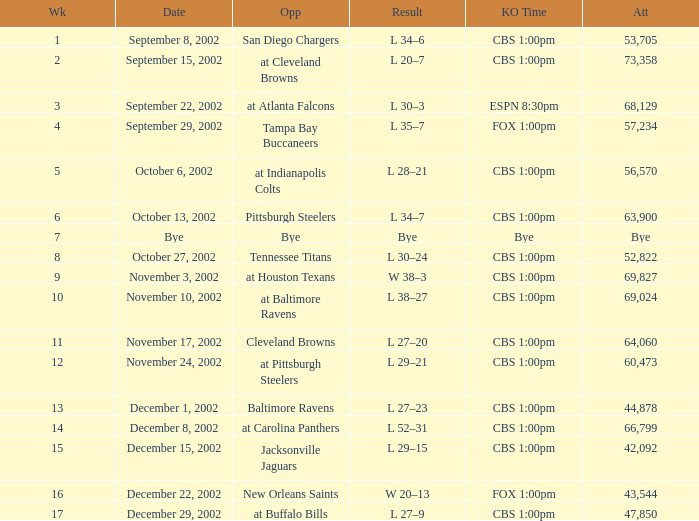Would you be able to parse every entry in this table? {'header': ['Wk', 'Date', 'Opp', 'Result', 'KO Time', 'Att'], 'rows': [['1', 'September 8, 2002', 'San Diego Chargers', 'L 34–6', 'CBS 1:00pm', '53,705'], ['2', 'September 15, 2002', 'at Cleveland Browns', 'L 20–7', 'CBS 1:00pm', '73,358'], ['3', 'September 22, 2002', 'at Atlanta Falcons', 'L 30–3', 'ESPN 8:30pm', '68,129'], ['4', 'September 29, 2002', 'Tampa Bay Buccaneers', 'L 35–7', 'FOX 1:00pm', '57,234'], ['5', 'October 6, 2002', 'at Indianapolis Colts', 'L 28–21', 'CBS 1:00pm', '56,570'], ['6', 'October 13, 2002', 'Pittsburgh Steelers', 'L 34–7', 'CBS 1:00pm', '63,900'], ['7', 'Bye', 'Bye', 'Bye', 'Bye', 'Bye'], ['8', 'October 27, 2002', 'Tennessee Titans', 'L 30–24', 'CBS 1:00pm', '52,822'], ['9', 'November 3, 2002', 'at Houston Texans', 'W 38–3', 'CBS 1:00pm', '69,827'], ['10', 'November 10, 2002', 'at Baltimore Ravens', 'L 38–27', 'CBS 1:00pm', '69,024'], ['11', 'November 17, 2002', 'Cleveland Browns', 'L 27–20', 'CBS 1:00pm', '64,060'], ['12', 'November 24, 2002', 'at Pittsburgh Steelers', 'L 29–21', 'CBS 1:00pm', '60,473'], ['13', 'December 1, 2002', 'Baltimore Ravens', 'L 27–23', 'CBS 1:00pm', '44,878'], ['14', 'December 8, 2002', 'at Carolina Panthers', 'L 52–31', 'CBS 1:00pm', '66,799'], ['15', 'December 15, 2002', 'Jacksonville Jaguars', 'L 29–15', 'CBS 1:00pm', '42,092'], ['16', 'December 22, 2002', 'New Orleans Saints', 'W 20–13', 'FOX 1:00pm', '43,544'], ['17', 'December 29, 2002', 'at Buffalo Bills', 'L 27–9', 'CBS 1:00pm', '47,850']]} What is the kickoff time for the game in week of 17? CBS 1:00pm. 